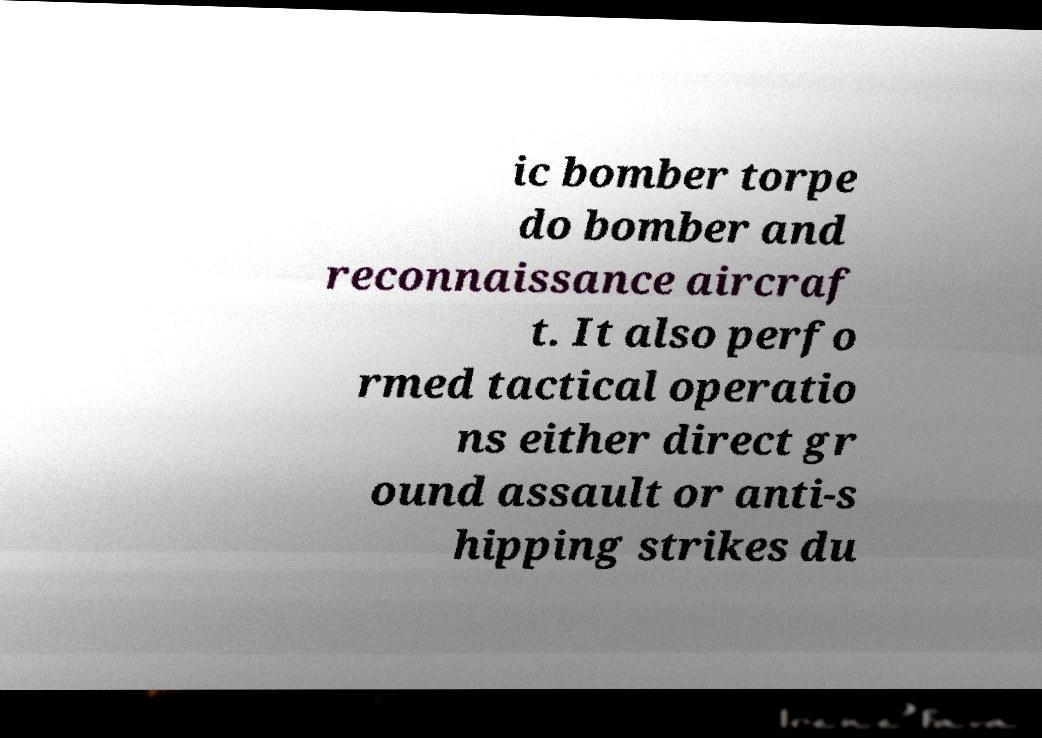Could you assist in decoding the text presented in this image and type it out clearly? ic bomber torpe do bomber and reconnaissance aircraf t. It also perfo rmed tactical operatio ns either direct gr ound assault or anti-s hipping strikes du 